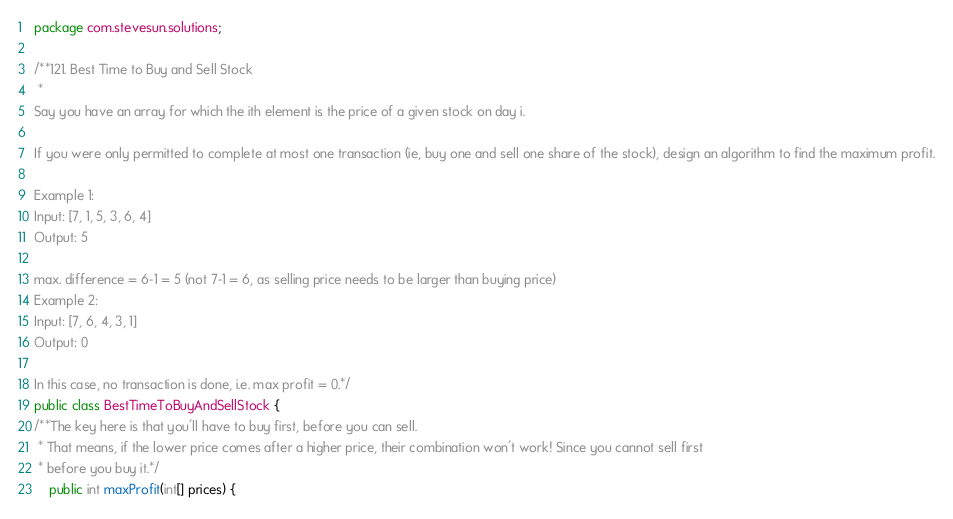<code> <loc_0><loc_0><loc_500><loc_500><_Java_>package com.stevesun.solutions;

/**121. Best Time to Buy and Sell Stock
 *
Say you have an array for which the ith element is the price of a given stock on day i.

If you were only permitted to complete at most one transaction (ie, buy one and sell one share of the stock), design an algorithm to find the maximum profit.

Example 1:
Input: [7, 1, 5, 3, 6, 4]
Output: 5

max. difference = 6-1 = 5 (not 7-1 = 6, as selling price needs to be larger than buying price)
Example 2:
Input: [7, 6, 4, 3, 1]
Output: 0

In this case, no transaction is done, i.e. max profit = 0.*/
public class BestTimeToBuyAndSellStock {
/**The key here is that you'll have to buy first, before you can sell.
 * That means, if the lower price comes after a higher price, their combination won't work! Since you cannot sell first
 * before you buy it.*/
    public int maxProfit(int[] prices) {</code> 